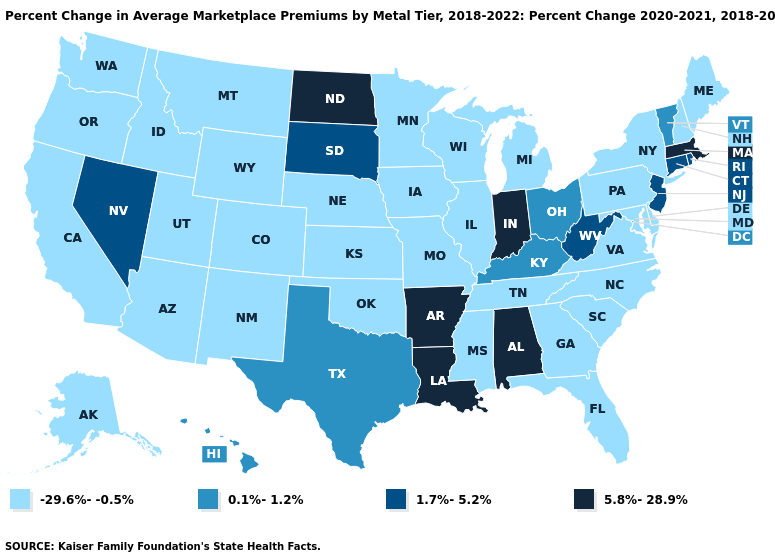Name the states that have a value in the range 5.8%-28.9%?
Short answer required. Alabama, Arkansas, Indiana, Louisiana, Massachusetts, North Dakota. What is the value of Louisiana?
Concise answer only. 5.8%-28.9%. Name the states that have a value in the range 0.1%-1.2%?
Give a very brief answer. Hawaii, Kentucky, Ohio, Texas, Vermont. Among the states that border Virginia , does Tennessee have the lowest value?
Write a very short answer. Yes. What is the value of Utah?
Give a very brief answer. -29.6%--0.5%. Name the states that have a value in the range 0.1%-1.2%?
Keep it brief. Hawaii, Kentucky, Ohio, Texas, Vermont. Does Indiana have the highest value in the MidWest?
Quick response, please. Yes. Name the states that have a value in the range 1.7%-5.2%?
Be succinct. Connecticut, Nevada, New Jersey, Rhode Island, South Dakota, West Virginia. Which states have the lowest value in the Northeast?
Give a very brief answer. Maine, New Hampshire, New York, Pennsylvania. Which states hav the highest value in the Northeast?
Short answer required. Massachusetts. What is the lowest value in states that border Montana?
Concise answer only. -29.6%--0.5%. Does Oklahoma have the highest value in the South?
Quick response, please. No. Name the states that have a value in the range 1.7%-5.2%?
Write a very short answer. Connecticut, Nevada, New Jersey, Rhode Island, South Dakota, West Virginia. What is the lowest value in the Northeast?
Concise answer only. -29.6%--0.5%. Does the map have missing data?
Keep it brief. No. 